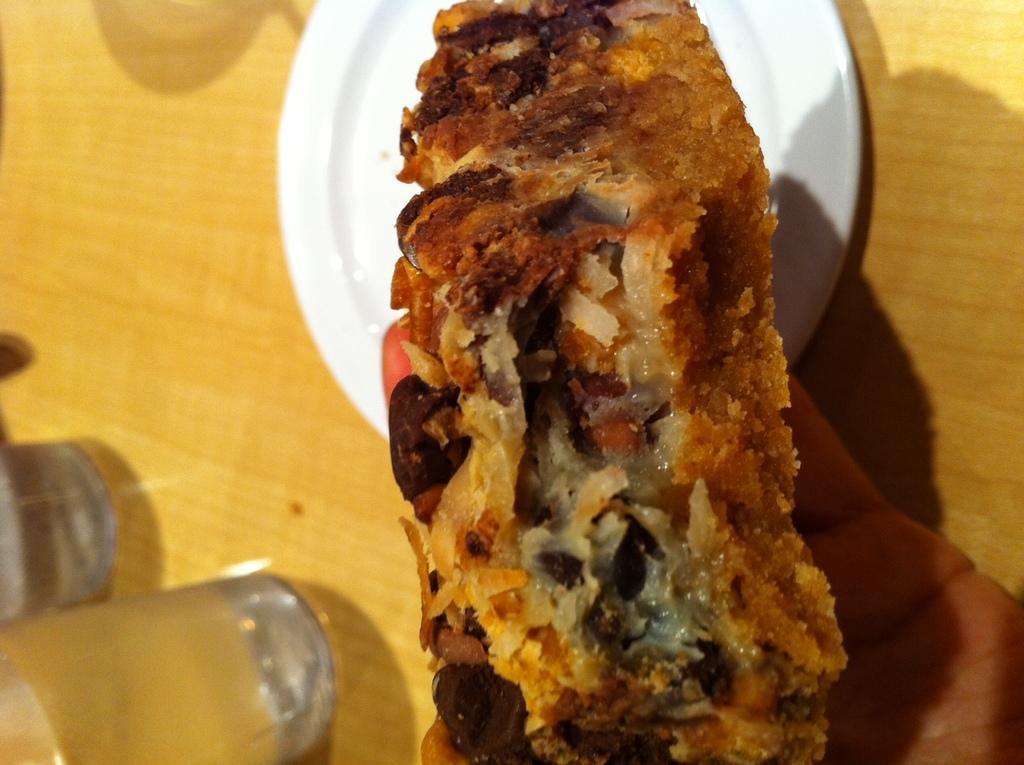Could you give a brief overview of what you see in this image? In this image we can see a hand holding a bread item. Here we can see a plate and glasses on the table. 